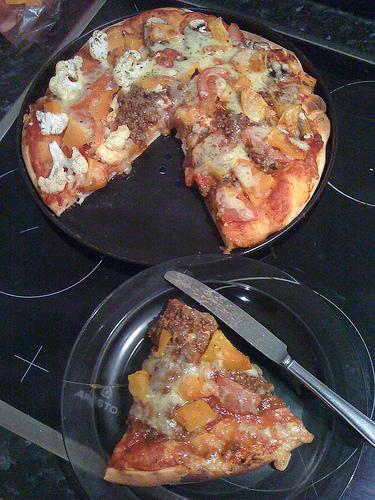How many slices of pizza are there?
Give a very brief answer. 4. How many slices are on the plate?
Give a very brief answer. 1. 